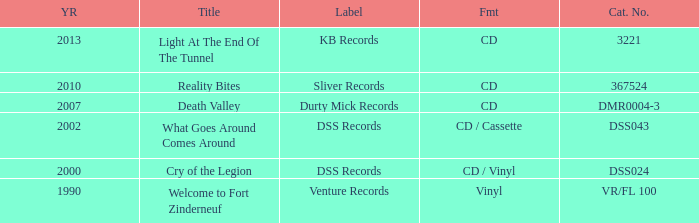What is the latest year of the album with the release title death valley? 2007.0. 